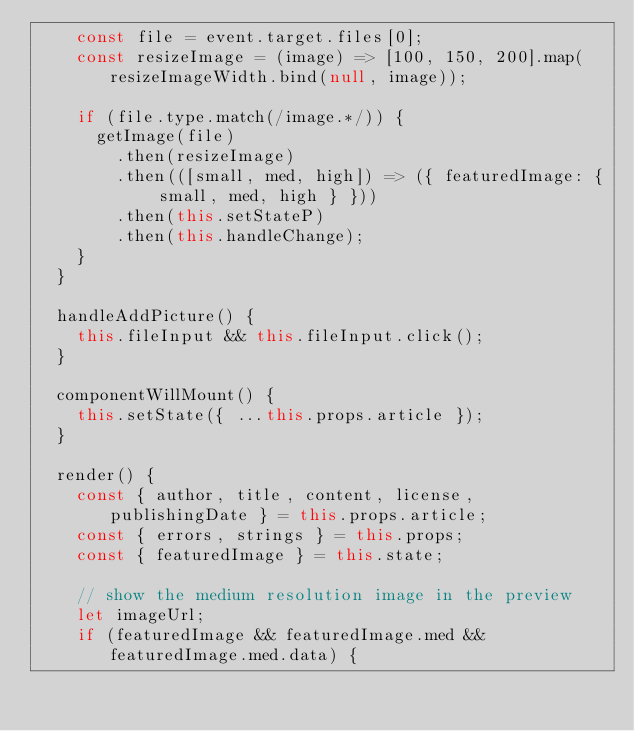<code> <loc_0><loc_0><loc_500><loc_500><_JavaScript_>    const file = event.target.files[0];
    const resizeImage = (image) => [100, 150, 200].map(resizeImageWidth.bind(null, image));

    if (file.type.match(/image.*/)) {
      getImage(file)
        .then(resizeImage)
        .then(([small, med, high]) => ({ featuredImage: { small, med, high } }))
        .then(this.setStateP)
        .then(this.handleChange);
    }
  }

  handleAddPicture() {
    this.fileInput && this.fileInput.click();
  }

  componentWillMount() {
    this.setState({ ...this.props.article });
  }

  render() {
    const { author, title, content, license, publishingDate } = this.props.article;
    const { errors, strings } = this.props;
    const { featuredImage } = this.state;

    // show the medium resolution image in the preview
    let imageUrl;
    if (featuredImage && featuredImage.med && featuredImage.med.data) {</code> 